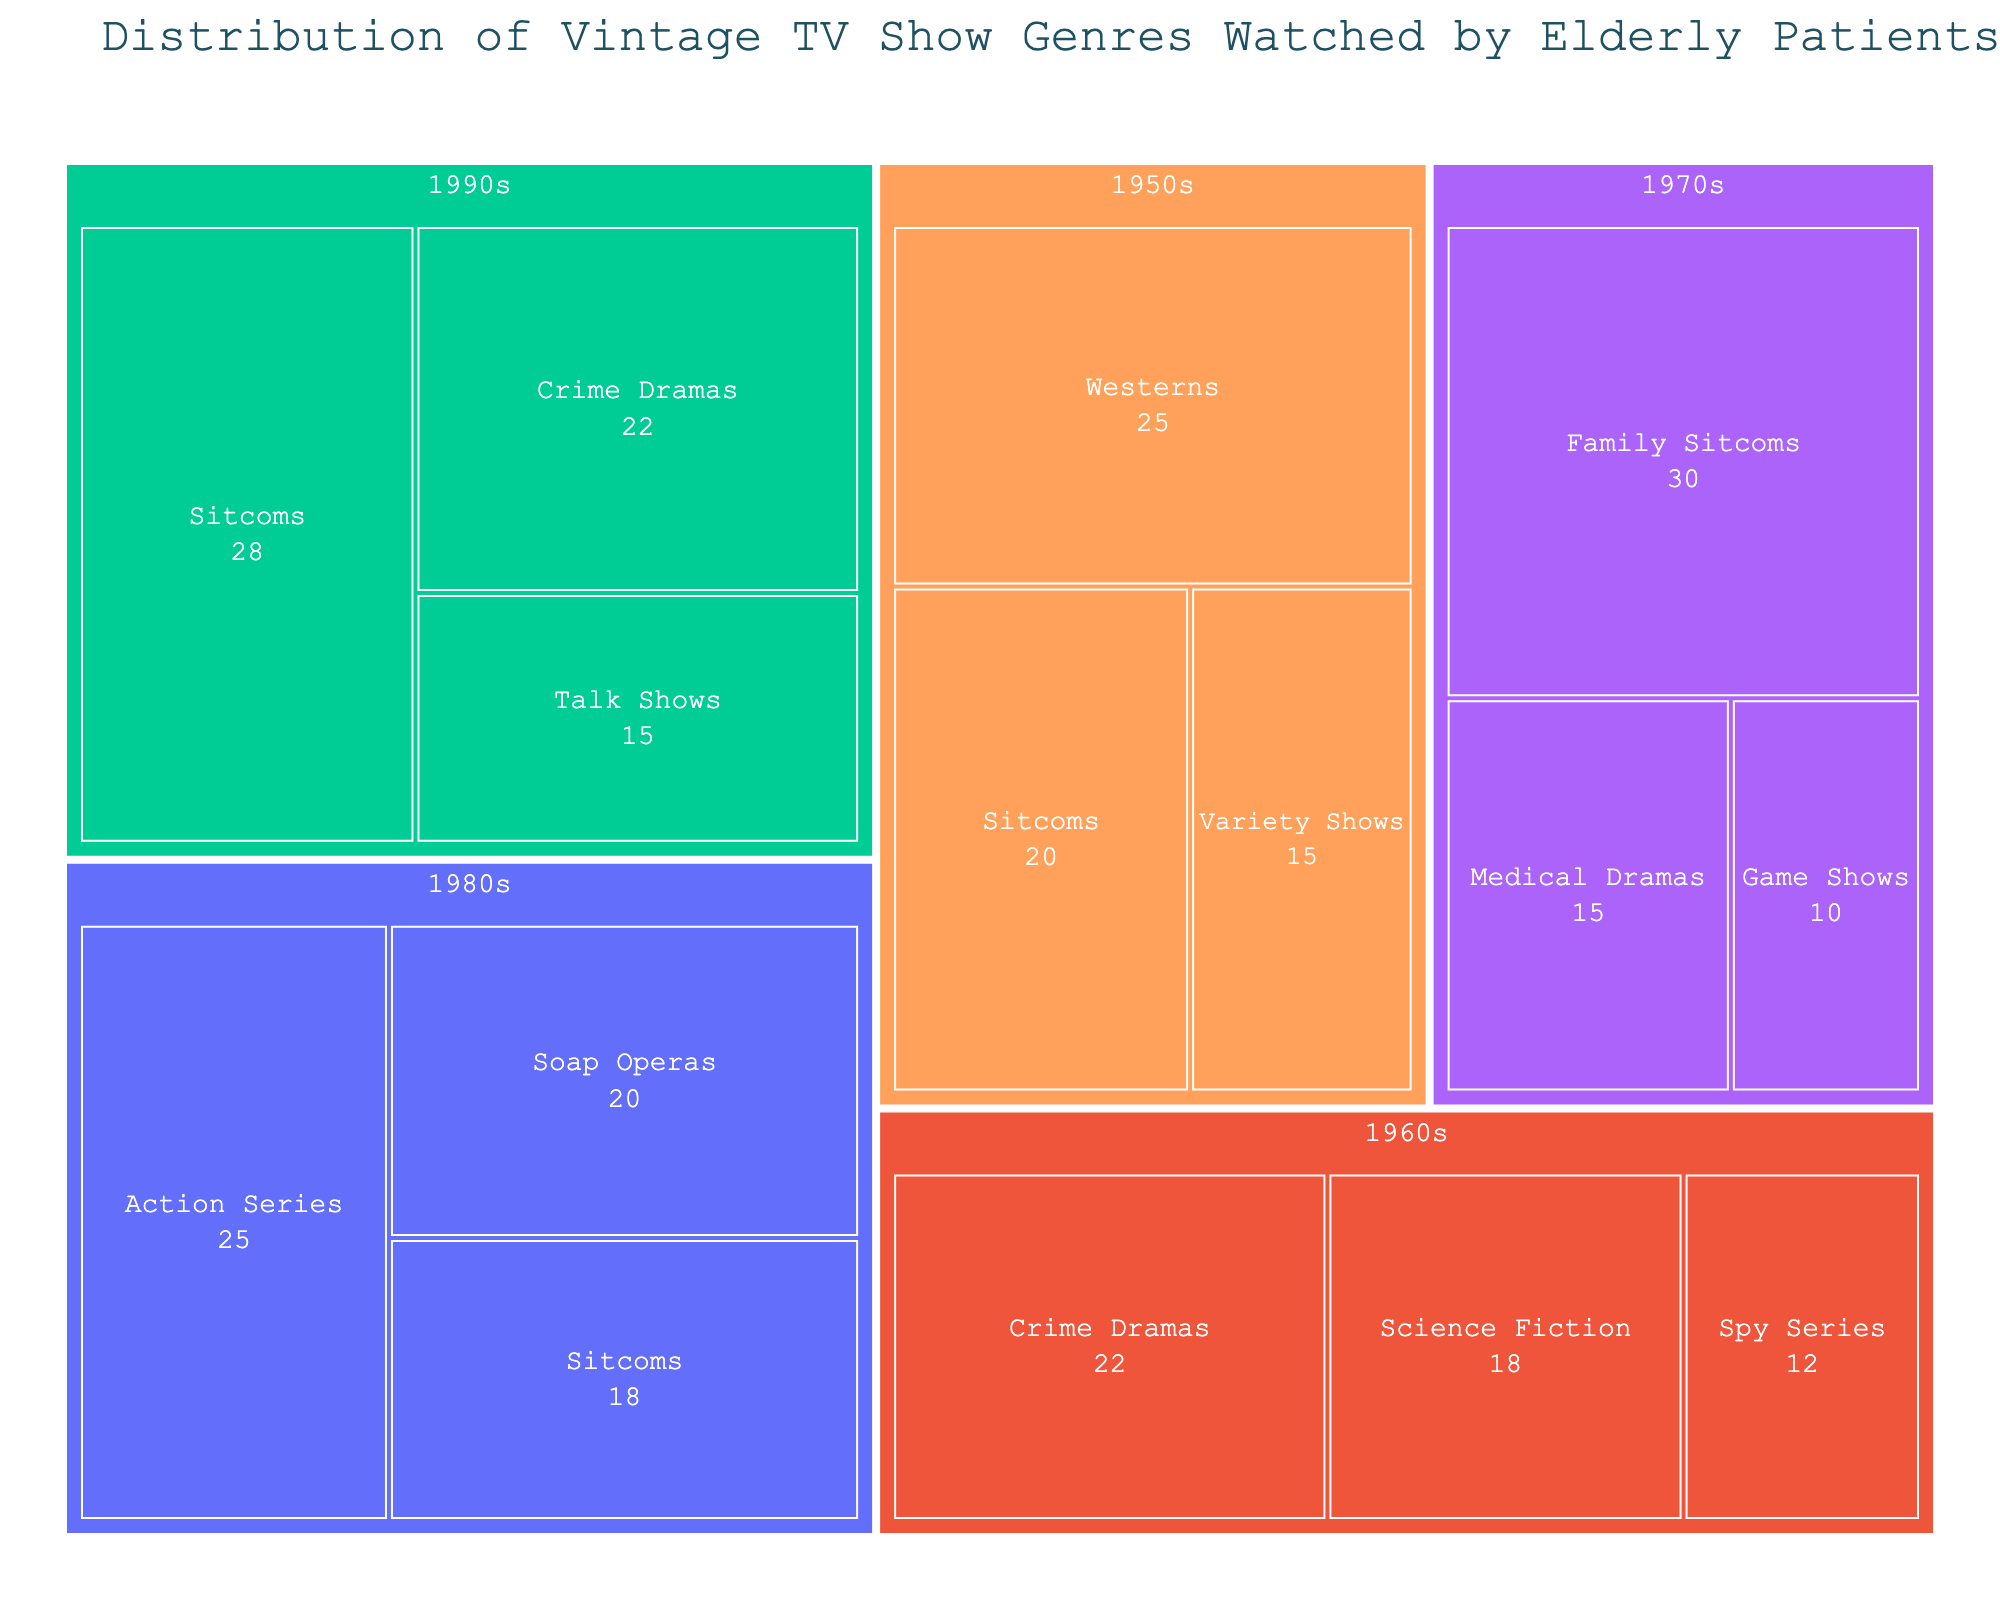What is the title of the treemap? The title is displayed at the top of the treemap and provides a summary of what the visualization represents.
Answer: Distribution of Vintage TV Show Genres Watched by Elderly Patients Which genre from the 1970s has the highest percentage? Look at the section of the treemap labeled "1970s" and identify the genre with the largest area or percentage.
Answer: Family Sitcoms What is the combined percentage of Sitcoms across all decades? Locate the Sitcoms in each decade (1950s, 1980s, and 1990s) and sum their percentages: 20% (1950s) + 18% (1980s) + 28% (1990s).
Answer: 66% Which decade has the widest variety of genres represented? Count the number of unique genres within each decade to determine which has the most categories. The 1950s have 3 genres, the 1960s have 3 genres, the 1970s have 3 genres, and the 1980s also have 3 genres. Compare these counts to the 1990s, which has 3 distinct genres.
Answer: All decades have 3 genres Which genre shows up in the most decades? Look across the sections for each decade and identify which genre appears in several decades. Sitcoms appear in the 1950s, 1980s, and 1990s.
Answer: Sitcoms What is the percentage of Science Fiction shows in the 1960s? Find the Science Fiction genre within the 1960s section of the treemap and note its corresponding percentage.
Answer: 18% If we combine the percentages of Westerns from the 1950s and Crime Dramas from the 1960s and 1990s, what is the total? Sum the percentages for Westerns from the 1950s (25%), Crime Dramas from the 1960s (22%), and Crime Dramas from the 1990s (22%): 25% + 22% + 22%.
Answer: 69% Which decade features the largest single genre by percentage? Examine each decade's sections and compare the percentage values of genres within each decade to find the largest. The largest genre in the 1950s is Westerns (25%), in the 1960s is Crime Dramas (22%), in the 1970s is Family Sitcoms (30%), in the 1980s is Action Series (25%), and in the 1990s is Sitcoms (28%). Identify the largest among these.
Answer: 1970s (Family Sitcoms, 30%) 